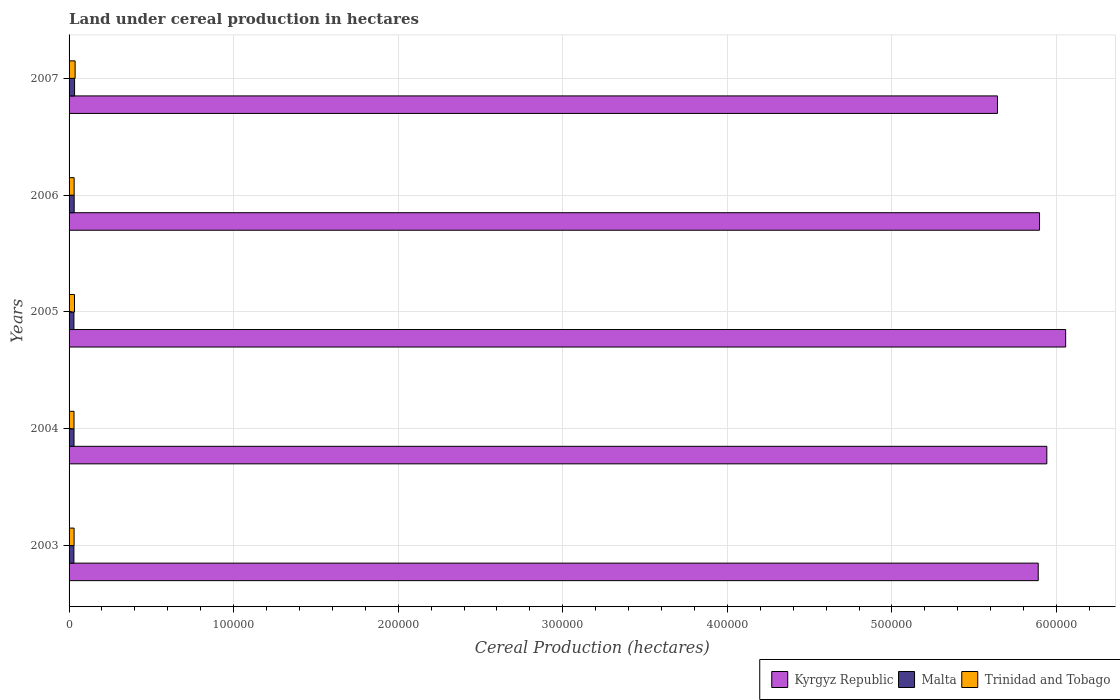How many different coloured bars are there?
Give a very brief answer. 3. Are the number of bars per tick equal to the number of legend labels?
Your answer should be very brief. Yes. How many bars are there on the 5th tick from the top?
Make the answer very short. 3. What is the label of the 1st group of bars from the top?
Provide a short and direct response. 2007. In how many cases, is the number of bars for a given year not equal to the number of legend labels?
Make the answer very short. 0. What is the land under cereal production in Kyrgyz Republic in 2006?
Provide a short and direct response. 5.90e+05. Across all years, what is the maximum land under cereal production in Trinidad and Tobago?
Make the answer very short. 3682. Across all years, what is the minimum land under cereal production in Trinidad and Tobago?
Provide a short and direct response. 3000. In which year was the land under cereal production in Kyrgyz Republic minimum?
Offer a terse response. 2007. What is the total land under cereal production in Trinidad and Tobago in the graph?
Offer a terse response. 1.61e+04. What is the difference between the land under cereal production in Malta in 2004 and that in 2005?
Keep it short and to the point. 64. What is the difference between the land under cereal production in Malta in 2006 and the land under cereal production in Kyrgyz Republic in 2007?
Give a very brief answer. -5.61e+05. What is the average land under cereal production in Kyrgyz Republic per year?
Make the answer very short. 5.88e+05. In the year 2006, what is the difference between the land under cereal production in Kyrgyz Republic and land under cereal production in Malta?
Provide a short and direct response. 5.87e+05. What is the ratio of the land under cereal production in Trinidad and Tobago in 2005 to that in 2006?
Keep it short and to the point. 1.07. What is the difference between the highest and the second highest land under cereal production in Kyrgyz Republic?
Your response must be concise. 1.14e+04. What is the difference between the highest and the lowest land under cereal production in Trinidad and Tobago?
Give a very brief answer. 682. What does the 2nd bar from the top in 2006 represents?
Ensure brevity in your answer.  Malta. What does the 1st bar from the bottom in 2005 represents?
Offer a terse response. Kyrgyz Republic. How many bars are there?
Your answer should be compact. 15. Are all the bars in the graph horizontal?
Your answer should be compact. Yes. How many years are there in the graph?
Give a very brief answer. 5. Does the graph contain grids?
Provide a short and direct response. Yes. Where does the legend appear in the graph?
Offer a very short reply. Bottom right. How many legend labels are there?
Your answer should be compact. 3. How are the legend labels stacked?
Offer a very short reply. Horizontal. What is the title of the graph?
Offer a terse response. Land under cereal production in hectares. Does "Latin America(all income levels)" appear as one of the legend labels in the graph?
Provide a short and direct response. No. What is the label or title of the X-axis?
Your answer should be very brief. Cereal Production (hectares). What is the Cereal Production (hectares) in Kyrgyz Republic in 2003?
Give a very brief answer. 5.89e+05. What is the Cereal Production (hectares) of Malta in 2003?
Offer a terse response. 2940. What is the Cereal Production (hectares) of Trinidad and Tobago in 2003?
Ensure brevity in your answer.  3050. What is the Cereal Production (hectares) in Kyrgyz Republic in 2004?
Ensure brevity in your answer.  5.94e+05. What is the Cereal Production (hectares) in Malta in 2004?
Provide a short and direct response. 3008. What is the Cereal Production (hectares) of Trinidad and Tobago in 2004?
Keep it short and to the point. 3000. What is the Cereal Production (hectares) of Kyrgyz Republic in 2005?
Offer a very short reply. 6.06e+05. What is the Cereal Production (hectares) in Malta in 2005?
Your answer should be very brief. 2944. What is the Cereal Production (hectares) of Trinidad and Tobago in 2005?
Offer a terse response. 3300. What is the Cereal Production (hectares) in Kyrgyz Republic in 2006?
Make the answer very short. 5.90e+05. What is the Cereal Production (hectares) in Malta in 2006?
Your answer should be very brief. 3100. What is the Cereal Production (hectares) of Trinidad and Tobago in 2006?
Provide a short and direct response. 3081. What is the Cereal Production (hectares) of Kyrgyz Republic in 2007?
Offer a terse response. 5.64e+05. What is the Cereal Production (hectares) in Malta in 2007?
Your response must be concise. 3350. What is the Cereal Production (hectares) in Trinidad and Tobago in 2007?
Make the answer very short. 3682. Across all years, what is the maximum Cereal Production (hectares) of Kyrgyz Republic?
Your answer should be very brief. 6.06e+05. Across all years, what is the maximum Cereal Production (hectares) of Malta?
Your answer should be very brief. 3350. Across all years, what is the maximum Cereal Production (hectares) of Trinidad and Tobago?
Give a very brief answer. 3682. Across all years, what is the minimum Cereal Production (hectares) of Kyrgyz Republic?
Keep it short and to the point. 5.64e+05. Across all years, what is the minimum Cereal Production (hectares) of Malta?
Give a very brief answer. 2940. Across all years, what is the minimum Cereal Production (hectares) of Trinidad and Tobago?
Ensure brevity in your answer.  3000. What is the total Cereal Production (hectares) in Kyrgyz Republic in the graph?
Offer a very short reply. 2.94e+06. What is the total Cereal Production (hectares) in Malta in the graph?
Offer a very short reply. 1.53e+04. What is the total Cereal Production (hectares) of Trinidad and Tobago in the graph?
Ensure brevity in your answer.  1.61e+04. What is the difference between the Cereal Production (hectares) of Kyrgyz Republic in 2003 and that in 2004?
Provide a short and direct response. -5221. What is the difference between the Cereal Production (hectares) in Malta in 2003 and that in 2004?
Provide a short and direct response. -68. What is the difference between the Cereal Production (hectares) of Trinidad and Tobago in 2003 and that in 2004?
Make the answer very short. 50. What is the difference between the Cereal Production (hectares) in Kyrgyz Republic in 2003 and that in 2005?
Give a very brief answer. -1.67e+04. What is the difference between the Cereal Production (hectares) in Malta in 2003 and that in 2005?
Make the answer very short. -4. What is the difference between the Cereal Production (hectares) in Trinidad and Tobago in 2003 and that in 2005?
Keep it short and to the point. -250. What is the difference between the Cereal Production (hectares) in Kyrgyz Republic in 2003 and that in 2006?
Your response must be concise. -787. What is the difference between the Cereal Production (hectares) in Malta in 2003 and that in 2006?
Offer a very short reply. -160. What is the difference between the Cereal Production (hectares) of Trinidad and Tobago in 2003 and that in 2006?
Provide a short and direct response. -31. What is the difference between the Cereal Production (hectares) in Kyrgyz Republic in 2003 and that in 2007?
Your answer should be compact. 2.48e+04. What is the difference between the Cereal Production (hectares) in Malta in 2003 and that in 2007?
Make the answer very short. -410. What is the difference between the Cereal Production (hectares) in Trinidad and Tobago in 2003 and that in 2007?
Provide a succinct answer. -632. What is the difference between the Cereal Production (hectares) in Kyrgyz Republic in 2004 and that in 2005?
Make the answer very short. -1.14e+04. What is the difference between the Cereal Production (hectares) in Malta in 2004 and that in 2005?
Your answer should be very brief. 64. What is the difference between the Cereal Production (hectares) in Trinidad and Tobago in 2004 and that in 2005?
Your answer should be very brief. -300. What is the difference between the Cereal Production (hectares) in Kyrgyz Republic in 2004 and that in 2006?
Your answer should be compact. 4434. What is the difference between the Cereal Production (hectares) of Malta in 2004 and that in 2006?
Provide a succinct answer. -92. What is the difference between the Cereal Production (hectares) in Trinidad and Tobago in 2004 and that in 2006?
Offer a very short reply. -81. What is the difference between the Cereal Production (hectares) of Kyrgyz Republic in 2004 and that in 2007?
Make the answer very short. 3.00e+04. What is the difference between the Cereal Production (hectares) in Malta in 2004 and that in 2007?
Provide a short and direct response. -342. What is the difference between the Cereal Production (hectares) of Trinidad and Tobago in 2004 and that in 2007?
Ensure brevity in your answer.  -682. What is the difference between the Cereal Production (hectares) in Kyrgyz Republic in 2005 and that in 2006?
Ensure brevity in your answer.  1.59e+04. What is the difference between the Cereal Production (hectares) of Malta in 2005 and that in 2006?
Your response must be concise. -156. What is the difference between the Cereal Production (hectares) in Trinidad and Tobago in 2005 and that in 2006?
Offer a terse response. 219. What is the difference between the Cereal Production (hectares) in Kyrgyz Republic in 2005 and that in 2007?
Your answer should be compact. 4.14e+04. What is the difference between the Cereal Production (hectares) in Malta in 2005 and that in 2007?
Make the answer very short. -406. What is the difference between the Cereal Production (hectares) of Trinidad and Tobago in 2005 and that in 2007?
Keep it short and to the point. -382. What is the difference between the Cereal Production (hectares) of Kyrgyz Republic in 2006 and that in 2007?
Ensure brevity in your answer.  2.56e+04. What is the difference between the Cereal Production (hectares) of Malta in 2006 and that in 2007?
Ensure brevity in your answer.  -250. What is the difference between the Cereal Production (hectares) of Trinidad and Tobago in 2006 and that in 2007?
Ensure brevity in your answer.  -601. What is the difference between the Cereal Production (hectares) in Kyrgyz Republic in 2003 and the Cereal Production (hectares) in Malta in 2004?
Offer a terse response. 5.86e+05. What is the difference between the Cereal Production (hectares) in Kyrgyz Republic in 2003 and the Cereal Production (hectares) in Trinidad and Tobago in 2004?
Offer a very short reply. 5.86e+05. What is the difference between the Cereal Production (hectares) of Malta in 2003 and the Cereal Production (hectares) of Trinidad and Tobago in 2004?
Provide a short and direct response. -60. What is the difference between the Cereal Production (hectares) of Kyrgyz Republic in 2003 and the Cereal Production (hectares) of Malta in 2005?
Keep it short and to the point. 5.86e+05. What is the difference between the Cereal Production (hectares) of Kyrgyz Republic in 2003 and the Cereal Production (hectares) of Trinidad and Tobago in 2005?
Keep it short and to the point. 5.86e+05. What is the difference between the Cereal Production (hectares) of Malta in 2003 and the Cereal Production (hectares) of Trinidad and Tobago in 2005?
Ensure brevity in your answer.  -360. What is the difference between the Cereal Production (hectares) of Kyrgyz Republic in 2003 and the Cereal Production (hectares) of Malta in 2006?
Keep it short and to the point. 5.86e+05. What is the difference between the Cereal Production (hectares) of Kyrgyz Republic in 2003 and the Cereal Production (hectares) of Trinidad and Tobago in 2006?
Give a very brief answer. 5.86e+05. What is the difference between the Cereal Production (hectares) in Malta in 2003 and the Cereal Production (hectares) in Trinidad and Tobago in 2006?
Your response must be concise. -141. What is the difference between the Cereal Production (hectares) of Kyrgyz Republic in 2003 and the Cereal Production (hectares) of Malta in 2007?
Give a very brief answer. 5.86e+05. What is the difference between the Cereal Production (hectares) of Kyrgyz Republic in 2003 and the Cereal Production (hectares) of Trinidad and Tobago in 2007?
Give a very brief answer. 5.85e+05. What is the difference between the Cereal Production (hectares) in Malta in 2003 and the Cereal Production (hectares) in Trinidad and Tobago in 2007?
Keep it short and to the point. -742. What is the difference between the Cereal Production (hectares) of Kyrgyz Republic in 2004 and the Cereal Production (hectares) of Malta in 2005?
Ensure brevity in your answer.  5.91e+05. What is the difference between the Cereal Production (hectares) of Kyrgyz Republic in 2004 and the Cereal Production (hectares) of Trinidad and Tobago in 2005?
Make the answer very short. 5.91e+05. What is the difference between the Cereal Production (hectares) in Malta in 2004 and the Cereal Production (hectares) in Trinidad and Tobago in 2005?
Ensure brevity in your answer.  -292. What is the difference between the Cereal Production (hectares) in Kyrgyz Republic in 2004 and the Cereal Production (hectares) in Malta in 2006?
Your answer should be very brief. 5.91e+05. What is the difference between the Cereal Production (hectares) of Kyrgyz Republic in 2004 and the Cereal Production (hectares) of Trinidad and Tobago in 2006?
Provide a succinct answer. 5.91e+05. What is the difference between the Cereal Production (hectares) of Malta in 2004 and the Cereal Production (hectares) of Trinidad and Tobago in 2006?
Ensure brevity in your answer.  -73. What is the difference between the Cereal Production (hectares) of Kyrgyz Republic in 2004 and the Cereal Production (hectares) of Malta in 2007?
Keep it short and to the point. 5.91e+05. What is the difference between the Cereal Production (hectares) in Kyrgyz Republic in 2004 and the Cereal Production (hectares) in Trinidad and Tobago in 2007?
Your answer should be very brief. 5.90e+05. What is the difference between the Cereal Production (hectares) of Malta in 2004 and the Cereal Production (hectares) of Trinidad and Tobago in 2007?
Keep it short and to the point. -674. What is the difference between the Cereal Production (hectares) of Kyrgyz Republic in 2005 and the Cereal Production (hectares) of Malta in 2006?
Your answer should be compact. 6.02e+05. What is the difference between the Cereal Production (hectares) in Kyrgyz Republic in 2005 and the Cereal Production (hectares) in Trinidad and Tobago in 2006?
Your answer should be very brief. 6.02e+05. What is the difference between the Cereal Production (hectares) of Malta in 2005 and the Cereal Production (hectares) of Trinidad and Tobago in 2006?
Provide a succinct answer. -137. What is the difference between the Cereal Production (hectares) of Kyrgyz Republic in 2005 and the Cereal Production (hectares) of Malta in 2007?
Ensure brevity in your answer.  6.02e+05. What is the difference between the Cereal Production (hectares) of Kyrgyz Republic in 2005 and the Cereal Production (hectares) of Trinidad and Tobago in 2007?
Your answer should be compact. 6.02e+05. What is the difference between the Cereal Production (hectares) of Malta in 2005 and the Cereal Production (hectares) of Trinidad and Tobago in 2007?
Give a very brief answer. -738. What is the difference between the Cereal Production (hectares) of Kyrgyz Republic in 2006 and the Cereal Production (hectares) of Malta in 2007?
Offer a terse response. 5.86e+05. What is the difference between the Cereal Production (hectares) of Kyrgyz Republic in 2006 and the Cereal Production (hectares) of Trinidad and Tobago in 2007?
Offer a very short reply. 5.86e+05. What is the difference between the Cereal Production (hectares) of Malta in 2006 and the Cereal Production (hectares) of Trinidad and Tobago in 2007?
Provide a succinct answer. -582. What is the average Cereal Production (hectares) in Kyrgyz Republic per year?
Your response must be concise. 5.88e+05. What is the average Cereal Production (hectares) in Malta per year?
Ensure brevity in your answer.  3068.4. What is the average Cereal Production (hectares) in Trinidad and Tobago per year?
Offer a very short reply. 3222.6. In the year 2003, what is the difference between the Cereal Production (hectares) in Kyrgyz Republic and Cereal Production (hectares) in Malta?
Make the answer very short. 5.86e+05. In the year 2003, what is the difference between the Cereal Production (hectares) of Kyrgyz Republic and Cereal Production (hectares) of Trinidad and Tobago?
Offer a very short reply. 5.86e+05. In the year 2003, what is the difference between the Cereal Production (hectares) of Malta and Cereal Production (hectares) of Trinidad and Tobago?
Keep it short and to the point. -110. In the year 2004, what is the difference between the Cereal Production (hectares) in Kyrgyz Republic and Cereal Production (hectares) in Malta?
Keep it short and to the point. 5.91e+05. In the year 2004, what is the difference between the Cereal Production (hectares) of Kyrgyz Republic and Cereal Production (hectares) of Trinidad and Tobago?
Give a very brief answer. 5.91e+05. In the year 2005, what is the difference between the Cereal Production (hectares) in Kyrgyz Republic and Cereal Production (hectares) in Malta?
Give a very brief answer. 6.03e+05. In the year 2005, what is the difference between the Cereal Production (hectares) of Kyrgyz Republic and Cereal Production (hectares) of Trinidad and Tobago?
Offer a terse response. 6.02e+05. In the year 2005, what is the difference between the Cereal Production (hectares) of Malta and Cereal Production (hectares) of Trinidad and Tobago?
Keep it short and to the point. -356. In the year 2006, what is the difference between the Cereal Production (hectares) in Kyrgyz Republic and Cereal Production (hectares) in Malta?
Make the answer very short. 5.87e+05. In the year 2006, what is the difference between the Cereal Production (hectares) of Kyrgyz Republic and Cereal Production (hectares) of Trinidad and Tobago?
Offer a terse response. 5.87e+05. In the year 2007, what is the difference between the Cereal Production (hectares) in Kyrgyz Republic and Cereal Production (hectares) in Malta?
Provide a short and direct response. 5.61e+05. In the year 2007, what is the difference between the Cereal Production (hectares) of Kyrgyz Republic and Cereal Production (hectares) of Trinidad and Tobago?
Ensure brevity in your answer.  5.60e+05. In the year 2007, what is the difference between the Cereal Production (hectares) in Malta and Cereal Production (hectares) in Trinidad and Tobago?
Ensure brevity in your answer.  -332. What is the ratio of the Cereal Production (hectares) of Kyrgyz Republic in 2003 to that in 2004?
Provide a short and direct response. 0.99. What is the ratio of the Cereal Production (hectares) in Malta in 2003 to that in 2004?
Offer a terse response. 0.98. What is the ratio of the Cereal Production (hectares) in Trinidad and Tobago in 2003 to that in 2004?
Your response must be concise. 1.02. What is the ratio of the Cereal Production (hectares) in Kyrgyz Republic in 2003 to that in 2005?
Offer a very short reply. 0.97. What is the ratio of the Cereal Production (hectares) in Malta in 2003 to that in 2005?
Provide a short and direct response. 1. What is the ratio of the Cereal Production (hectares) in Trinidad and Tobago in 2003 to that in 2005?
Your answer should be compact. 0.92. What is the ratio of the Cereal Production (hectares) of Malta in 2003 to that in 2006?
Provide a short and direct response. 0.95. What is the ratio of the Cereal Production (hectares) of Trinidad and Tobago in 2003 to that in 2006?
Make the answer very short. 0.99. What is the ratio of the Cereal Production (hectares) in Kyrgyz Republic in 2003 to that in 2007?
Make the answer very short. 1.04. What is the ratio of the Cereal Production (hectares) of Malta in 2003 to that in 2007?
Offer a very short reply. 0.88. What is the ratio of the Cereal Production (hectares) in Trinidad and Tobago in 2003 to that in 2007?
Offer a very short reply. 0.83. What is the ratio of the Cereal Production (hectares) in Kyrgyz Republic in 2004 to that in 2005?
Ensure brevity in your answer.  0.98. What is the ratio of the Cereal Production (hectares) in Malta in 2004 to that in 2005?
Offer a terse response. 1.02. What is the ratio of the Cereal Production (hectares) of Kyrgyz Republic in 2004 to that in 2006?
Give a very brief answer. 1.01. What is the ratio of the Cereal Production (hectares) in Malta in 2004 to that in 2006?
Offer a very short reply. 0.97. What is the ratio of the Cereal Production (hectares) of Trinidad and Tobago in 2004 to that in 2006?
Make the answer very short. 0.97. What is the ratio of the Cereal Production (hectares) in Kyrgyz Republic in 2004 to that in 2007?
Provide a succinct answer. 1.05. What is the ratio of the Cereal Production (hectares) in Malta in 2004 to that in 2007?
Offer a very short reply. 0.9. What is the ratio of the Cereal Production (hectares) of Trinidad and Tobago in 2004 to that in 2007?
Provide a short and direct response. 0.81. What is the ratio of the Cereal Production (hectares) of Kyrgyz Republic in 2005 to that in 2006?
Offer a very short reply. 1.03. What is the ratio of the Cereal Production (hectares) of Malta in 2005 to that in 2006?
Keep it short and to the point. 0.95. What is the ratio of the Cereal Production (hectares) in Trinidad and Tobago in 2005 to that in 2006?
Give a very brief answer. 1.07. What is the ratio of the Cereal Production (hectares) in Kyrgyz Republic in 2005 to that in 2007?
Offer a terse response. 1.07. What is the ratio of the Cereal Production (hectares) of Malta in 2005 to that in 2007?
Your answer should be very brief. 0.88. What is the ratio of the Cereal Production (hectares) of Trinidad and Tobago in 2005 to that in 2007?
Provide a short and direct response. 0.9. What is the ratio of the Cereal Production (hectares) in Kyrgyz Republic in 2006 to that in 2007?
Your response must be concise. 1.05. What is the ratio of the Cereal Production (hectares) of Malta in 2006 to that in 2007?
Ensure brevity in your answer.  0.93. What is the ratio of the Cereal Production (hectares) of Trinidad and Tobago in 2006 to that in 2007?
Keep it short and to the point. 0.84. What is the difference between the highest and the second highest Cereal Production (hectares) in Kyrgyz Republic?
Offer a terse response. 1.14e+04. What is the difference between the highest and the second highest Cereal Production (hectares) of Malta?
Provide a short and direct response. 250. What is the difference between the highest and the second highest Cereal Production (hectares) in Trinidad and Tobago?
Provide a short and direct response. 382. What is the difference between the highest and the lowest Cereal Production (hectares) of Kyrgyz Republic?
Offer a very short reply. 4.14e+04. What is the difference between the highest and the lowest Cereal Production (hectares) of Malta?
Your response must be concise. 410. What is the difference between the highest and the lowest Cereal Production (hectares) of Trinidad and Tobago?
Provide a succinct answer. 682. 